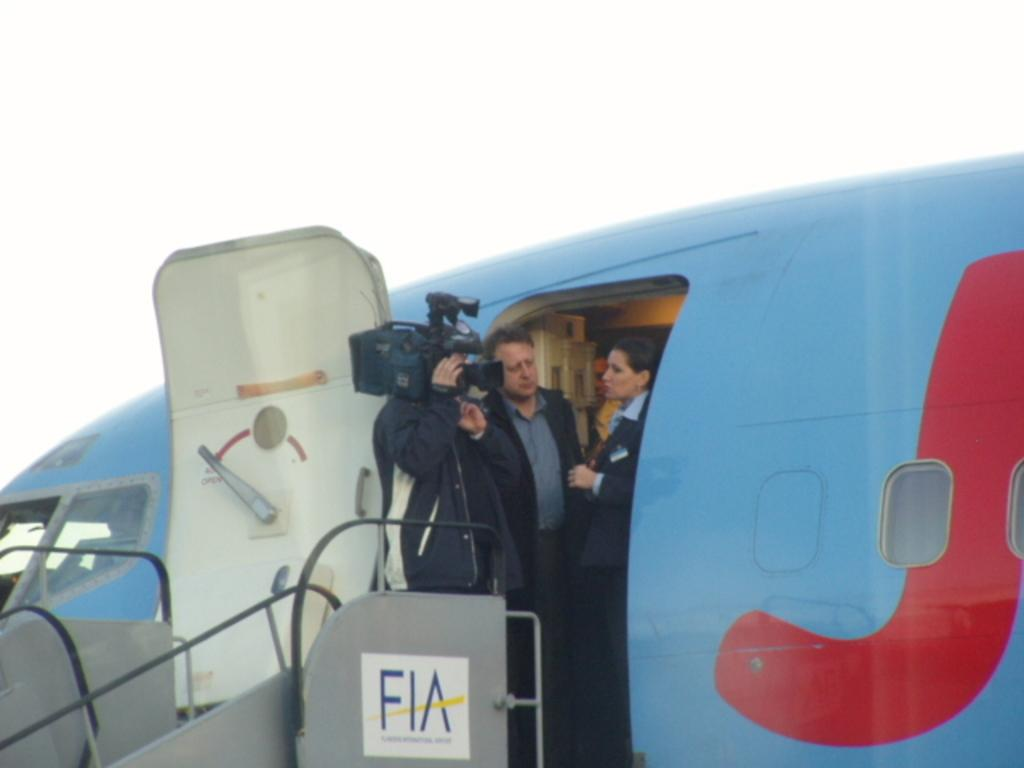<image>
Create a compact narrative representing the image presented. A camera man and person are exiting an airplane and stepping onto the stairs to go down and the stairs have a sign that says FIA. 